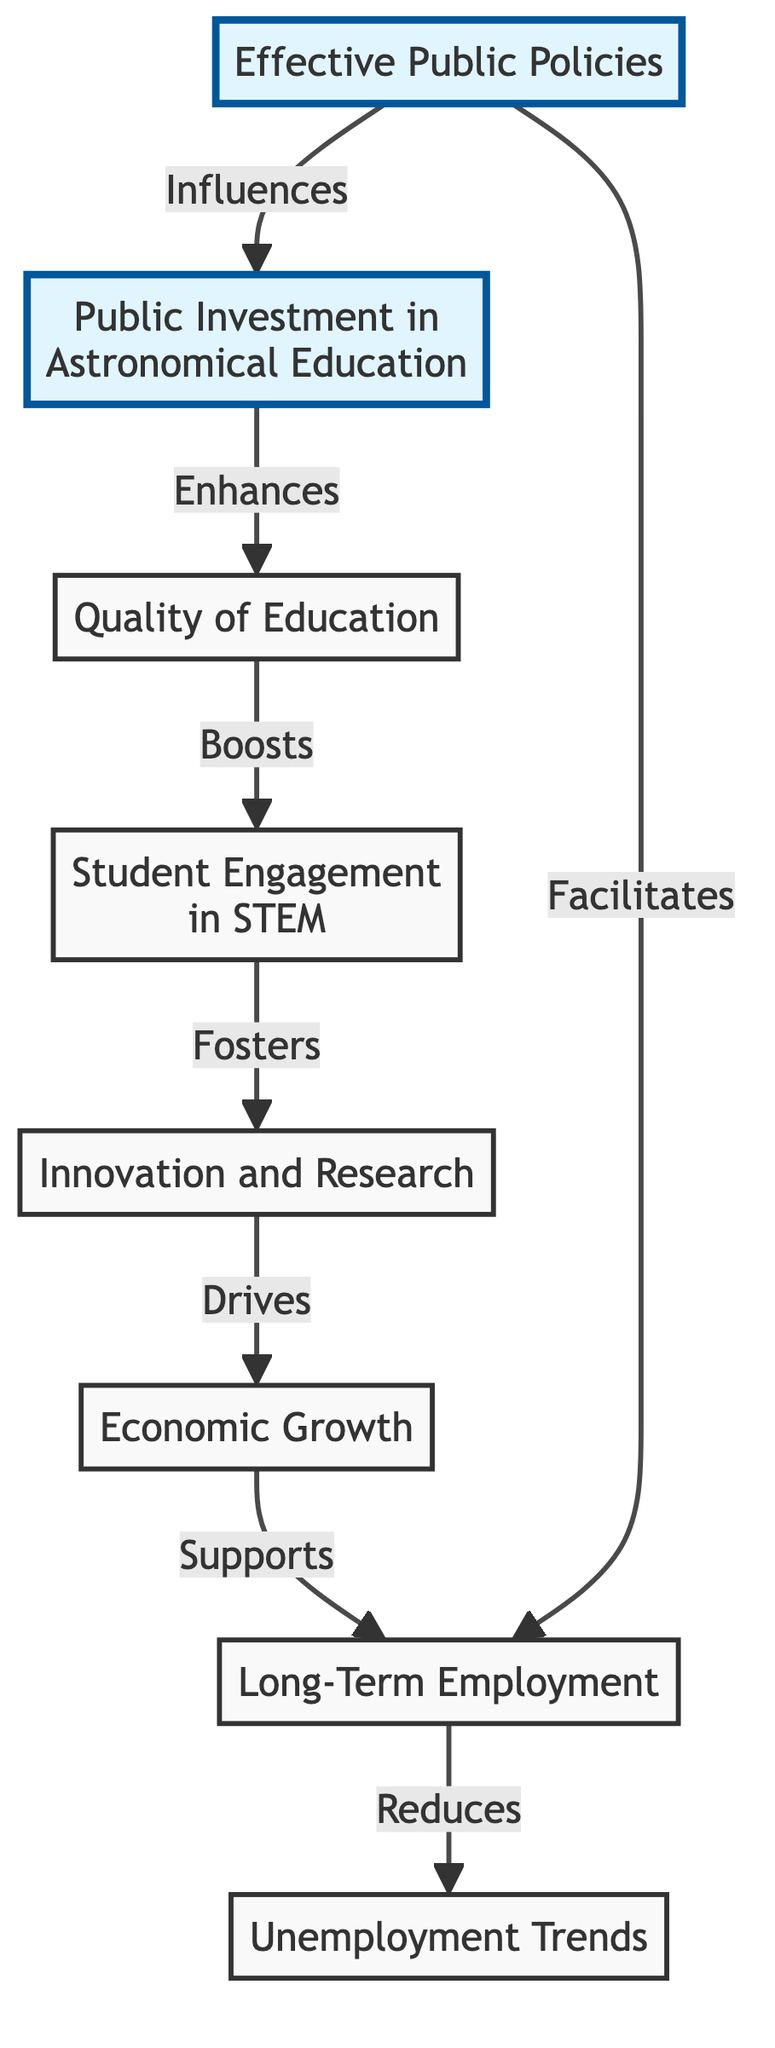What is the initial node in the diagram? The initial node in the diagram is "Public Investment in Astronomical Education", which indicates the starting point of the flow in the diagram.
Answer: Public Investment in Astronomical Education How many nodes are in the diagram? By counting each block in the diagram, there are a total of eight distinct nodes that represent different stages of the flow from public investment to unemployment trends.
Answer: Eight Which node connects public investment directly to quality of education? The node that connects public investment directly to quality of education is labeled as "Quality of Education", which follows directly from the "Public Investment in Astronomical Education".
Answer: Quality of Education What effect does innovation and research have on economic growth? Innovation and research lead to economic growth, as illustrated in the diagram where "Innovation and Research" flows into "Economic Growth", indicating a direct relationship.
Answer: Drives Which node indicates the influence of effective public policies? The node indicating the influence of effective public policies is "Effective Public Policies", which shows a direct connection to both "Public Investment in Astronomical Education" and "Long-Term Employment".
Answer: Effective Public Policies How does quality of education contribute to long-term employment? Quality of education enhances student engagement in STEM, which is a step before promoting innovation and research that eventually drives economic growth, leading to long-term employment.
Answer: Boosts What is the final outcome node in the flow? The final outcome node at the end of the flowchart is labeled "Unemployment Trends", representing the ultimate impact of the preceding nodes on long-term unemployment.
Answer: Unemployment Trends Explain the connection between student engagement in STEM and unemployment trends. Student engagement in STEM boosts innovation and research efforts, which in turn drives economic growth; this growth ultimately supports long-term employment, which reduces unemployment trends.
Answer: Reduces 